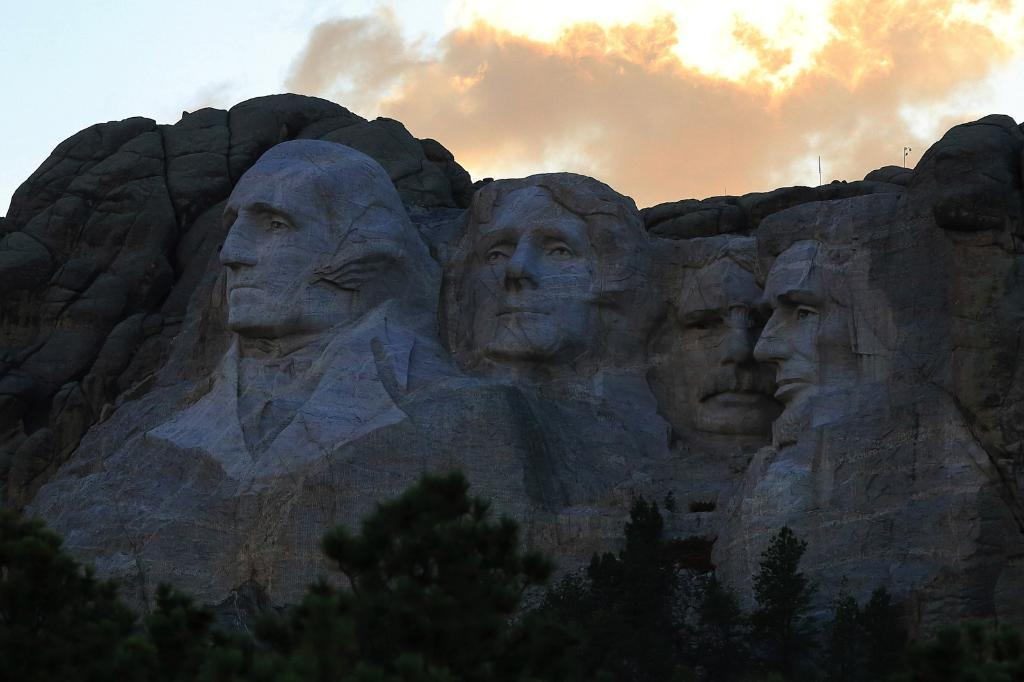What is carved on the rock in the image? There is a carving of persons' faces on a rock in the image. What type of vegetation can be seen in the image? There are trees with green color in the image. What is visible in the sky in the image? The sky is visible in the image, with white and blue colors. What type of hen can be seen cooking in the image? There is no hen or cooking activity present in the image. 